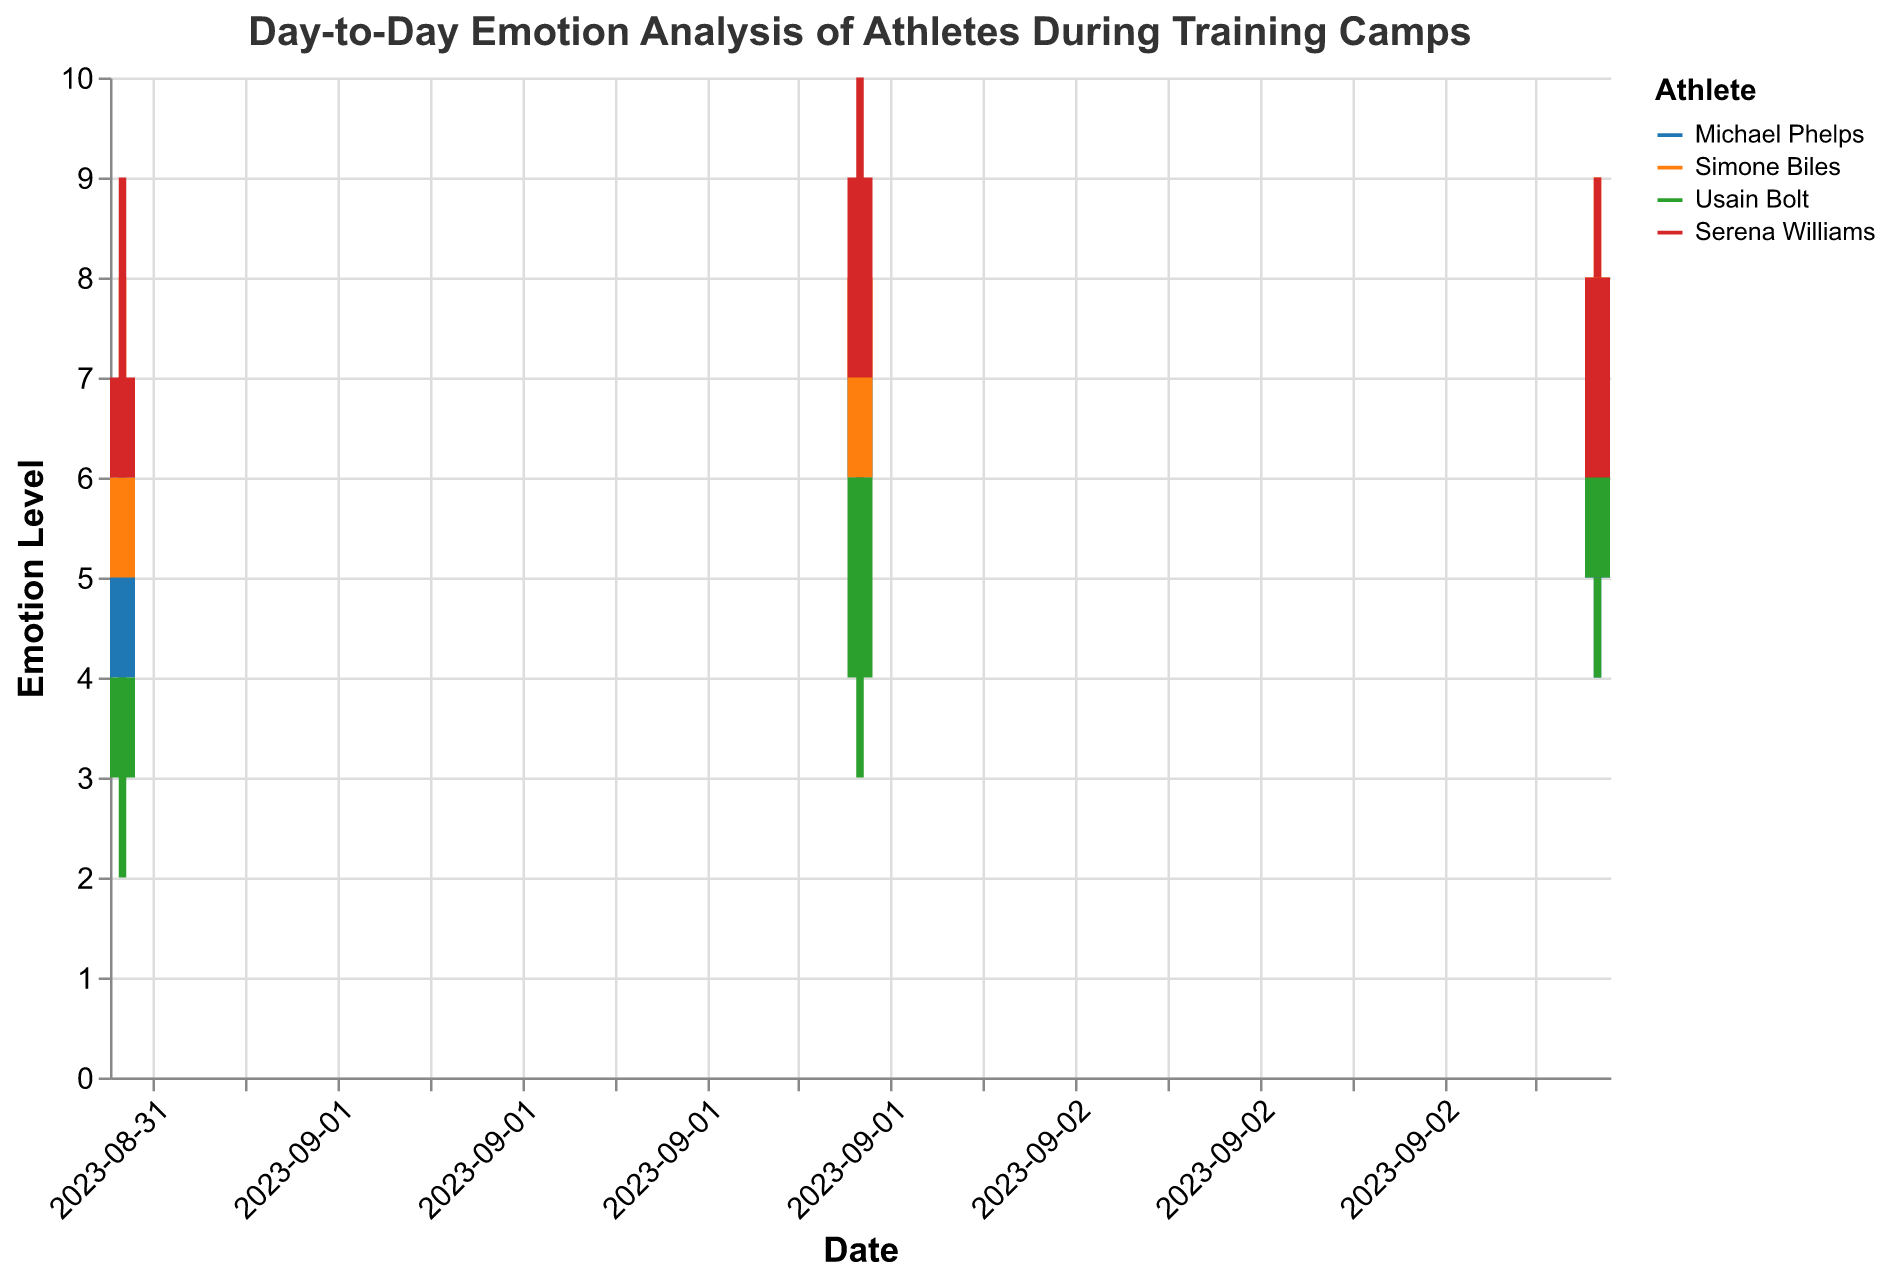What is the title of the figure? The title of the figure is usually placed at the top and is meant to describe what the figure is about. In this case, it's "Day-to-Day Emotion Analysis of Athletes During Training Camps".
Answer: Day-to-Day Emotion Analysis of Athletes During Training Camps Which athlete had the highest emotion level on 2023-09-01? To find this, check the 'High Emotion' values for each athlete on the date 2023-09-01. Michael Phelps: 7, Simone Biles: 8, Usain Bolt: 6, Serena Williams: 9. The highest value is 9, which belongs to Serena Williams.
Answer: Serena Williams On 2023-09-02, how much did Michael Phelps' closing emotion change compared to his opening emotion? Look at Michael Phelps' values on 2023-09-02. He had an opening emotion of 6 and a closing emotion of 7. The change is Closing Emotion - Opening Emotion = 7 - 6 = 1.
Answer: 1 Which athlete showed the most significant improvement in their closing emotion from 2023-09-01 to 2023-09-02? Calculate the improvement in closing emotion for each athlete: 
- Michael Phelps: 7 - 6 = 1
- Simone Biles: 8 - 6 = 2
- Usain Bolt: 6 - 4 = 2
- Serena Williams: 9 - 7 = 2
Simone Biles, Usain Bolt, and Serena Williams showed equal improvement of 2.
Answer: Simone Biles, Usain Bolt, Serena Williams For which athlete did the daily low emotion remain consistently above 3? Examine the 'Low Emotion' values for each athlete across all dates. 
- Michael Phelps: 3, 5, 4 (not consistently above 3)
- Simone Biles: 4, 5, 6 (consistently above 3)
- Usain Bolt: 2, 3, 4 (not consistently above 3)
- Serena Williams: 5, 6, 5 (consistently above 3)
Only Simone Biles and Serena Williams have values consistently above 3.
Answer: Simone Biles, Serena Williams How did Usain Bolt’s emotional range (high emotion - low emotion) change from 2023-09-01 to 2023-09-03? Calculate the range for each day:
- 2023-09-01: 6 - 2 = 4
- 2023-09-02: 7 - 3 = 4
- 2023-09-03: 8 - 4 = 4
Usain Bolt's emotional range remained the same, 4, on each day.
Answer: No Change Which athlete experienced the smallest fluctuation in emotions on 2023-09-03? Compare the ranges:
- Michael Phelps: 7 - 4 = 3
- Simone Biles: 9 - 6 = 3
- Usain Bolt: 8 - 4 = 4
- Serena Williams: 9 - 5 = 4
Tied for the smallest fluctuation (3) are Michael Phelps and Simone Biles.
Answer: Michael Phelps, Simone Biles What was the overall emotional trend of Serena Williams from 2023-09-01 to 2023-09-03, based on the opening emotion values? Check the 'Opening Emotion' values for Serena Williams:
- 2023-09-01: 6
- 2023-09-02: 7
- 2023-09-03: 6
Serena Williams's opening emotion increased from 6 to 7 and then returned to 6. The trend is stable with a slight increase in the middle.
Answer: Stable with slight increase On which date did Simone Biles' closing emotion peak? Look at Simone Biles' closing emotion values for each date:
- 2023-09-01: 6
- 2023-09-02: 8
- 2023-09-03: 8
Her peak closing emotion is 8, occurring on both 2023-09-02 and 2023-09-03.
Answer: 2023-09-02, 2023-09-03 What’s the average high emotion level for all athletes on 2023-09-02? Add up the high emotion values for each athlete on 2023-09-02 and divide by the number of athletes:
- Michael Phelps: 8
- Simone Biles: 9
- Usain Bolt: 7
- Serena Williams: 10
Sum = 8 + 9 + 7 + 10 = 34, Average = 34 / 4 = 8.5.
Answer: 8.5 